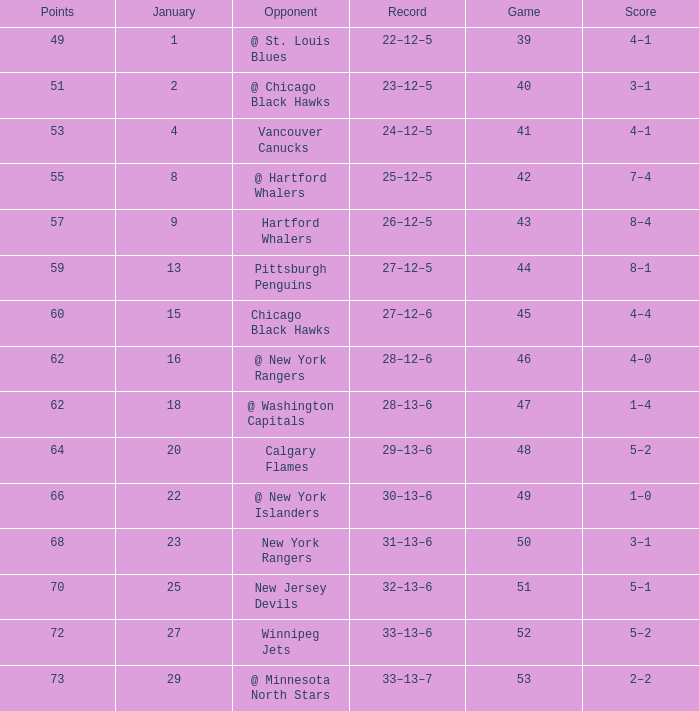Which Points have a Score of 4–1, and a Game smaller than 39? None. 